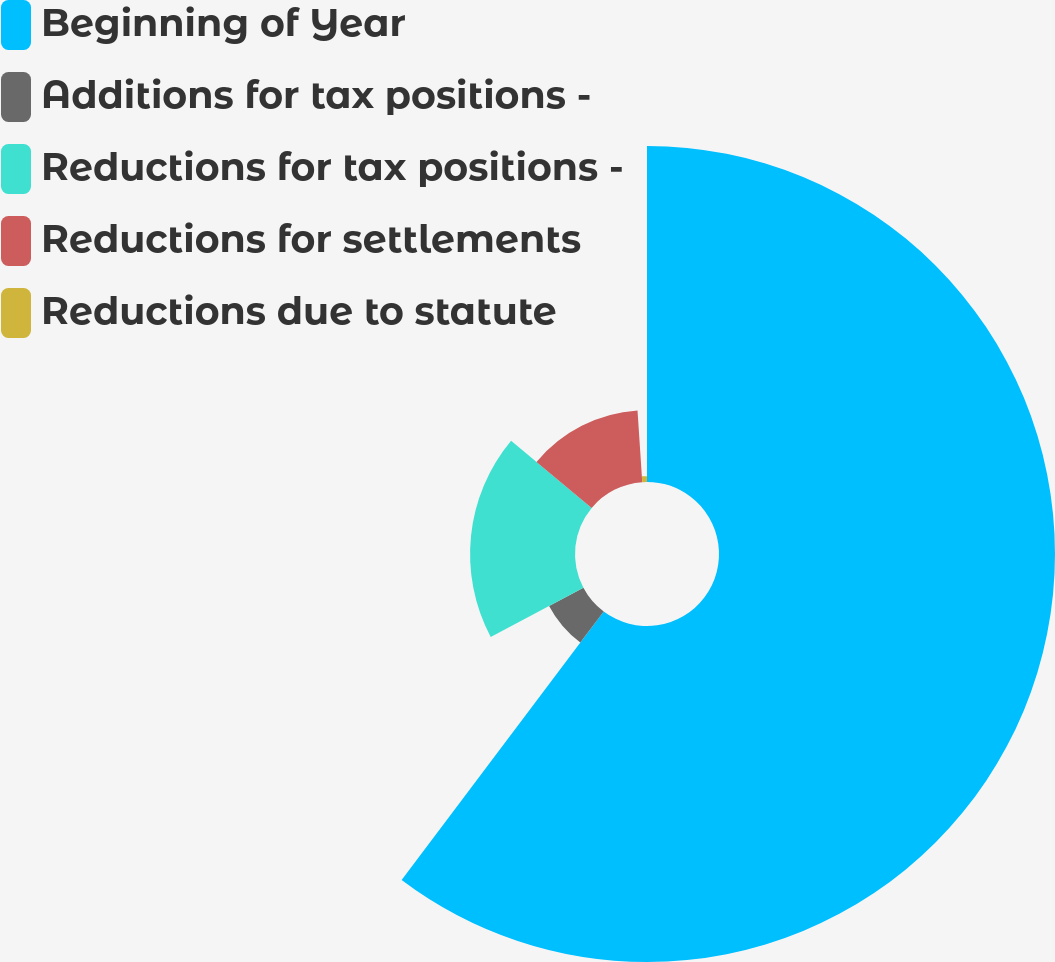Convert chart. <chart><loc_0><loc_0><loc_500><loc_500><pie_chart><fcel>Beginning of Year<fcel>Additions for tax positions -<fcel>Reductions for tax positions -<fcel>Reductions for settlements<fcel>Reductions due to statute<nl><fcel>60.27%<fcel>6.97%<fcel>18.82%<fcel>12.89%<fcel>1.05%<nl></chart> 